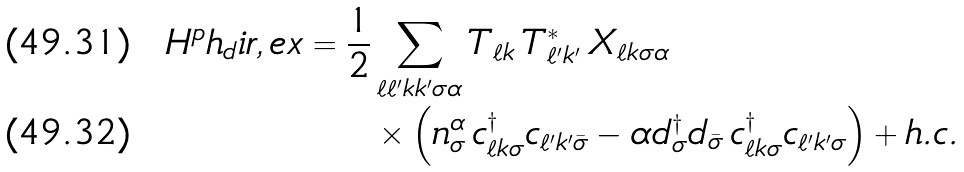Convert formula to latex. <formula><loc_0><loc_0><loc_500><loc_500>H ^ { p } h _ { d } i r , e x = \frac { 1 } { 2 } & \sum _ { \ell \ell ^ { \prime } k k ^ { \prime } \sigma \alpha } T _ { \ell k } \, T _ { \ell ^ { \prime } k ^ { \prime } } ^ { \ast } \, X _ { \ell k \sigma \alpha } \\ & \times \left ( n ^ { \alpha } _ { \sigma } \, c ^ { \dagger } _ { \ell k \sigma } c _ { \ell ^ { \prime } k ^ { \prime } \bar { \sigma } } - \alpha d ^ { \dagger } _ { \sigma } d _ { \bar { \sigma } } \, c ^ { \dagger } _ { \ell k \sigma } c _ { \ell ^ { \prime } k ^ { \prime } \sigma } \right ) + h . c .</formula> 